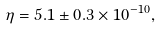Convert formula to latex. <formula><loc_0><loc_0><loc_500><loc_500>\eta = 5 . 1 \pm 0 . 3 \times 1 0 ^ { - 1 0 } ,</formula> 